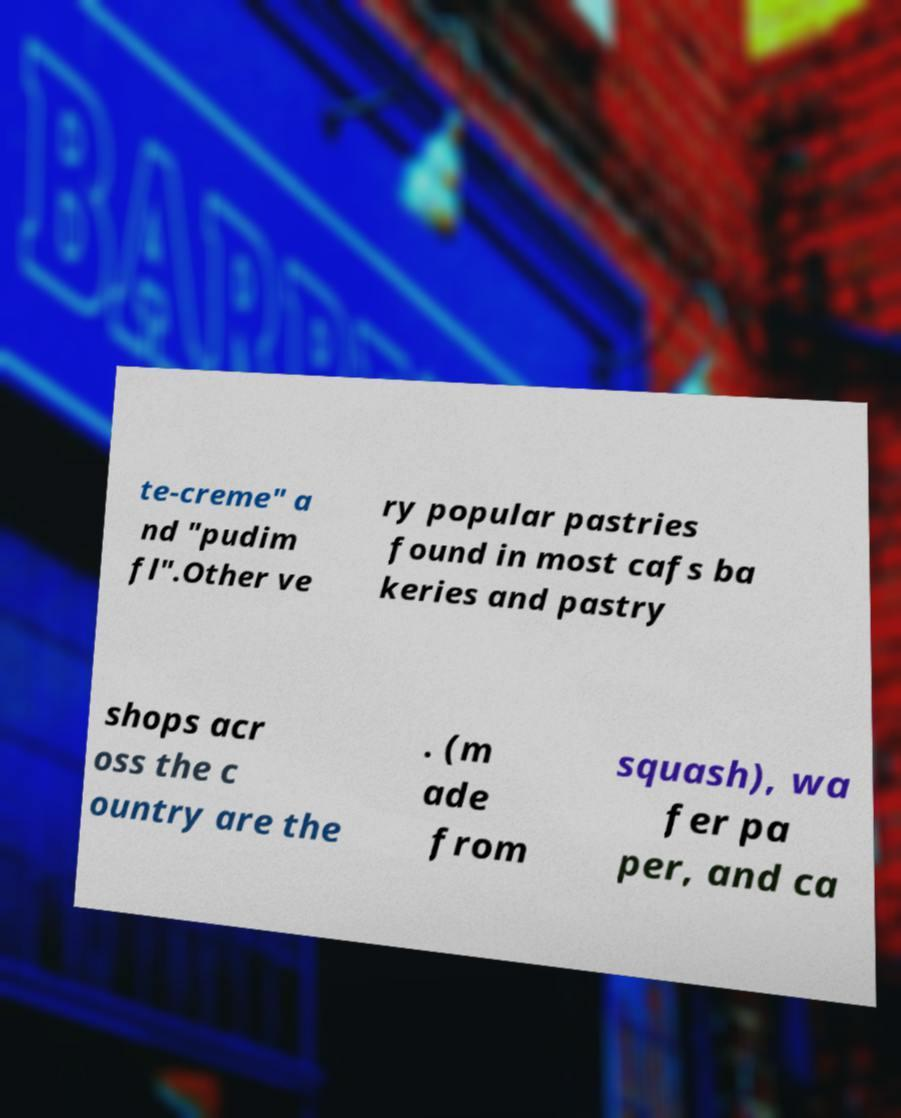Please identify and transcribe the text found in this image. te-creme" a nd "pudim fl".Other ve ry popular pastries found in most cafs ba keries and pastry shops acr oss the c ountry are the . (m ade from squash), wa fer pa per, and ca 